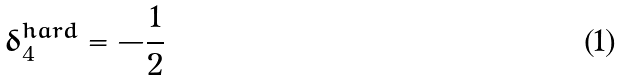<formula> <loc_0><loc_0><loc_500><loc_500>\delta _ { 4 } ^ { h a r d } = - \frac { 1 } { 2 }</formula> 